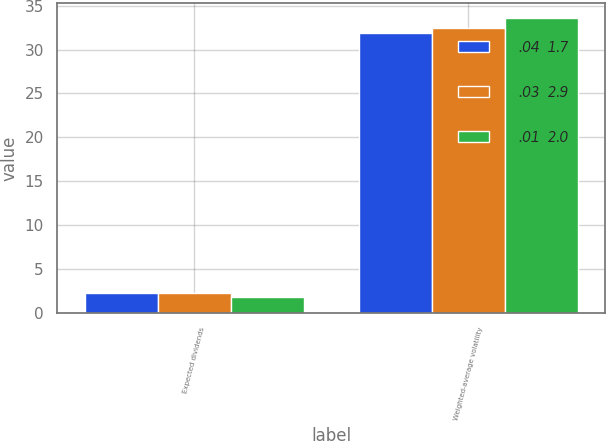Convert chart. <chart><loc_0><loc_0><loc_500><loc_500><stacked_bar_chart><ecel><fcel>Expected dividends<fcel>Weighted-average volatility<nl><fcel>.04  1.7<fcel>2.3<fcel>31.9<nl><fcel>.03  2.9<fcel>2.3<fcel>32.4<nl><fcel>.01  2.0<fcel>1.9<fcel>33.6<nl></chart> 